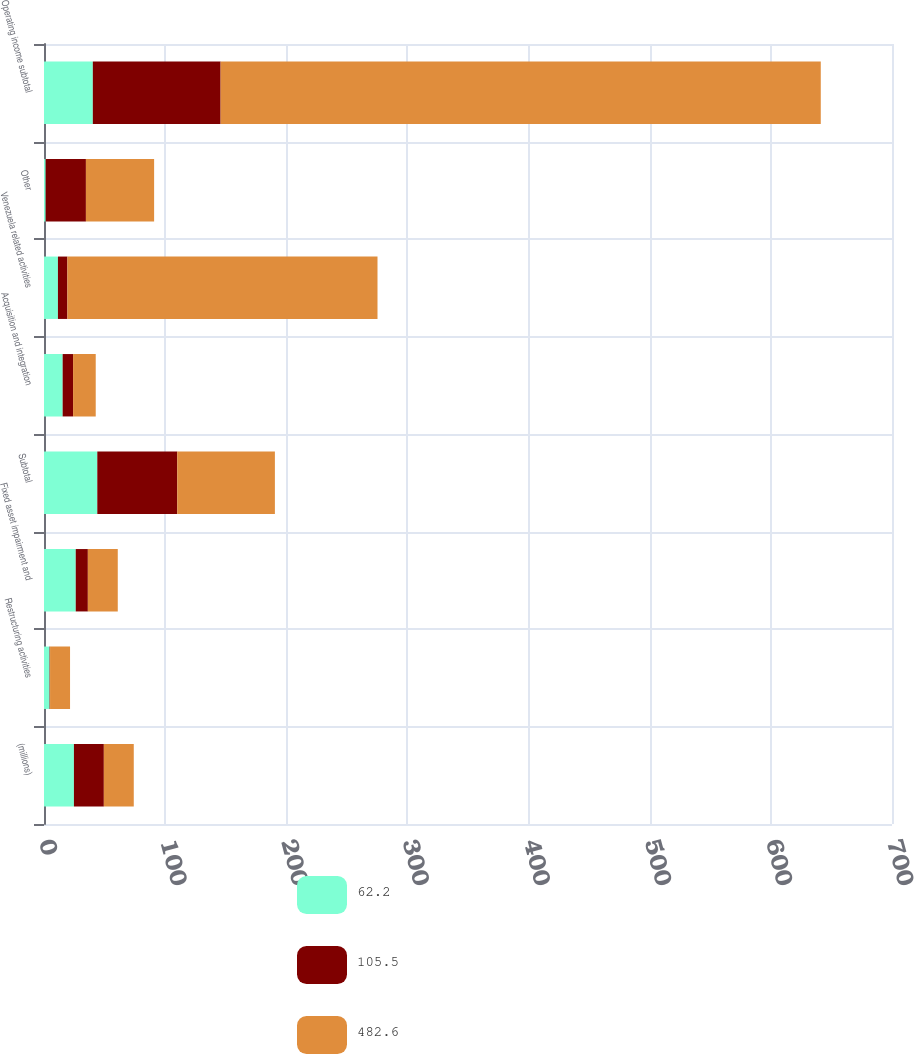<chart> <loc_0><loc_0><loc_500><loc_500><stacked_bar_chart><ecel><fcel>(millions)<fcel>Restructuring activities<fcel>Fixed asset impairment and<fcel>Subtotal<fcel>Acquisition and integration<fcel>Venezuela related activities<fcel>Other<fcel>Operating income subtotal<nl><fcel>62.2<fcel>24.7<fcel>4.6<fcel>26.2<fcel>44<fcel>15.4<fcel>11.5<fcel>1.4<fcel>40.3<nl><fcel>105.5<fcel>24.7<fcel>0.4<fcel>10<fcel>66<fcel>8.6<fcel>7.8<fcel>33.2<fcel>105.5<nl><fcel>482.6<fcel>24.7<fcel>16.5<fcel>24.7<fcel>80.6<fcel>18.7<fcel>256<fcel>56.3<fcel>495.4<nl></chart> 